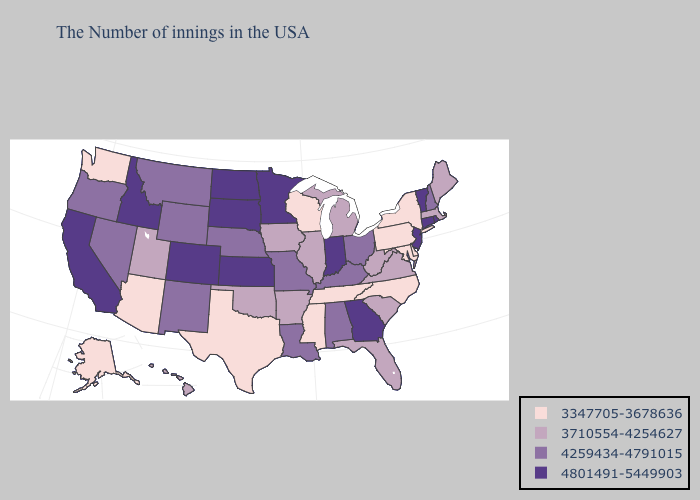Does Delaware have a higher value than Hawaii?
Concise answer only. No. What is the highest value in the West ?
Keep it brief. 4801491-5449903. Does West Virginia have the highest value in the USA?
Quick response, please. No. What is the highest value in states that border North Dakota?
Short answer required. 4801491-5449903. Name the states that have a value in the range 4801491-5449903?
Answer briefly. Rhode Island, Vermont, Connecticut, New Jersey, Georgia, Indiana, Minnesota, Kansas, South Dakota, North Dakota, Colorado, Idaho, California. Which states have the lowest value in the MidWest?
Short answer required. Wisconsin. Is the legend a continuous bar?
Answer briefly. No. What is the value of Washington?
Keep it brief. 3347705-3678636. Name the states that have a value in the range 4801491-5449903?
Concise answer only. Rhode Island, Vermont, Connecticut, New Jersey, Georgia, Indiana, Minnesota, Kansas, South Dakota, North Dakota, Colorado, Idaho, California. What is the value of Virginia?
Short answer required. 3710554-4254627. Does Maine have the highest value in the USA?
Be succinct. No. Name the states that have a value in the range 3710554-4254627?
Give a very brief answer. Maine, Massachusetts, Virginia, South Carolina, West Virginia, Florida, Michigan, Illinois, Arkansas, Iowa, Oklahoma, Utah, Hawaii. Name the states that have a value in the range 3347705-3678636?
Concise answer only. New York, Delaware, Maryland, Pennsylvania, North Carolina, Tennessee, Wisconsin, Mississippi, Texas, Arizona, Washington, Alaska. Does Montana have a lower value than Arkansas?
Be succinct. No. 